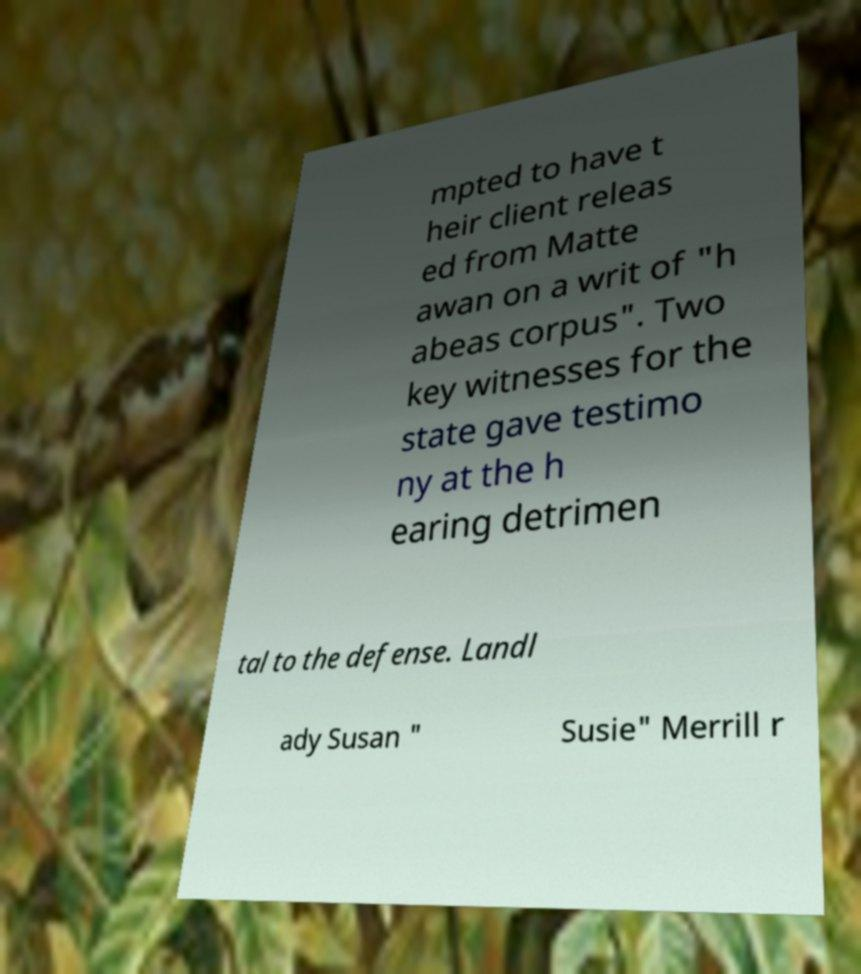Could you extract and type out the text from this image? mpted to have t heir client releas ed from Matte awan on a writ of "h abeas corpus". Two key witnesses for the state gave testimo ny at the h earing detrimen tal to the defense. Landl ady Susan " Susie" Merrill r 